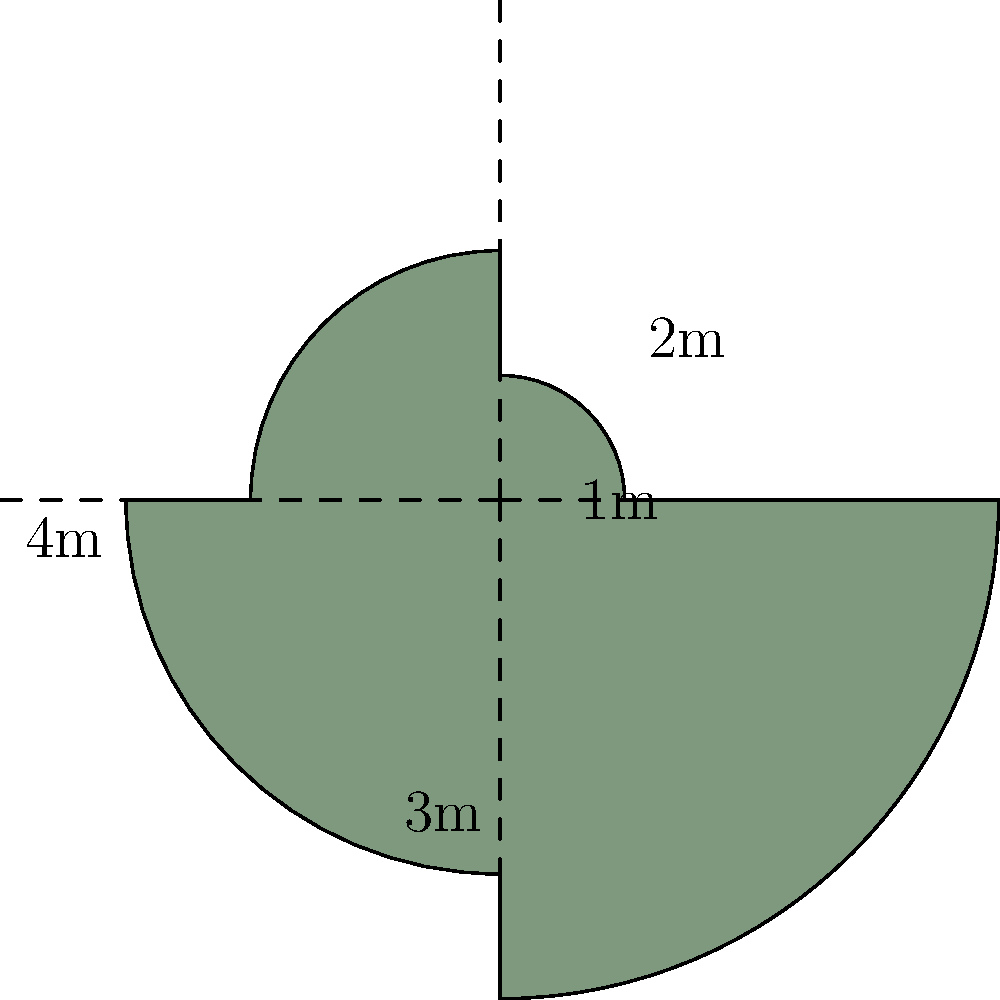A unique spiral-shaped garden plot has been designed with four quadrants, each forming a quarter circle. The radii of these quadrants increase by 1 meter for each successive quadrant, starting from 1 meter for the innermost quadrant. Calculate the total perimeter and area of this intriguing garden plot. Express your answer in terms of $\pi$ where applicable, and round any decimal results to two decimal places. Let's approach this step-by-step:

1) Perimeter calculation:
   The perimeter consists of four quarter-circle arcs.
   
   Arc lengths:
   - First quadrant: $\frac{1}{4} \cdot 2\pi r_1 = \frac{\pi}{2}$ m
   - Second quadrant: $\frac{1}{4} \cdot 2\pi r_2 = \pi$ m
   - Third quadrant: $\frac{1}{4} \cdot 2\pi r_3 = \frac{3\pi}{2}$ m
   - Fourth quadrant: $\frac{1}{4} \cdot 2\pi r_4 = 2\pi$ m

   Total perimeter = $\frac{\pi}{2} + \pi + \frac{3\pi}{2} + 2\pi = 5\pi$ m

2) Area calculation:
   The area is the sum of four quarter-circle areas.
   
   Areas:
   - First quadrant: $\frac{1}{4} \cdot \pi r_1^2 = \frac{\pi}{4}$ m²
   - Second quadrant: $\frac{1}{4} \cdot \pi r_2^2 = \pi$ m²
   - Third quadrant: $\frac{1}{4} \cdot \pi r_3^2 = \frac{9\pi}{4}$ m²
   - Fourth quadrant: $\frac{1}{4} \cdot \pi r_4^2 = 4\pi$ m²

   Total area = $\frac{\pi}{4} + \pi + \frac{9\pi}{4} + 4\pi = \frac{25\pi}{4}$ m²

3) Rounding:
   Perimeter: $5\pi \approx 15.71$ m
   Area: $\frac{25\pi}{4} \approx 19.63$ m²
Answer: Perimeter: $5\pi$ m ($\approx 15.71$ m), Area: $\frac{25\pi}{4}$ m² ($\approx 19.63$ m²) 